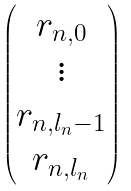<formula> <loc_0><loc_0><loc_500><loc_500>\begin{pmatrix} r _ { n , 0 } \\ \vdots \\ r _ { n , l _ { n } - 1 } \\ r _ { n , l _ { n } } \\ \end{pmatrix}</formula> 